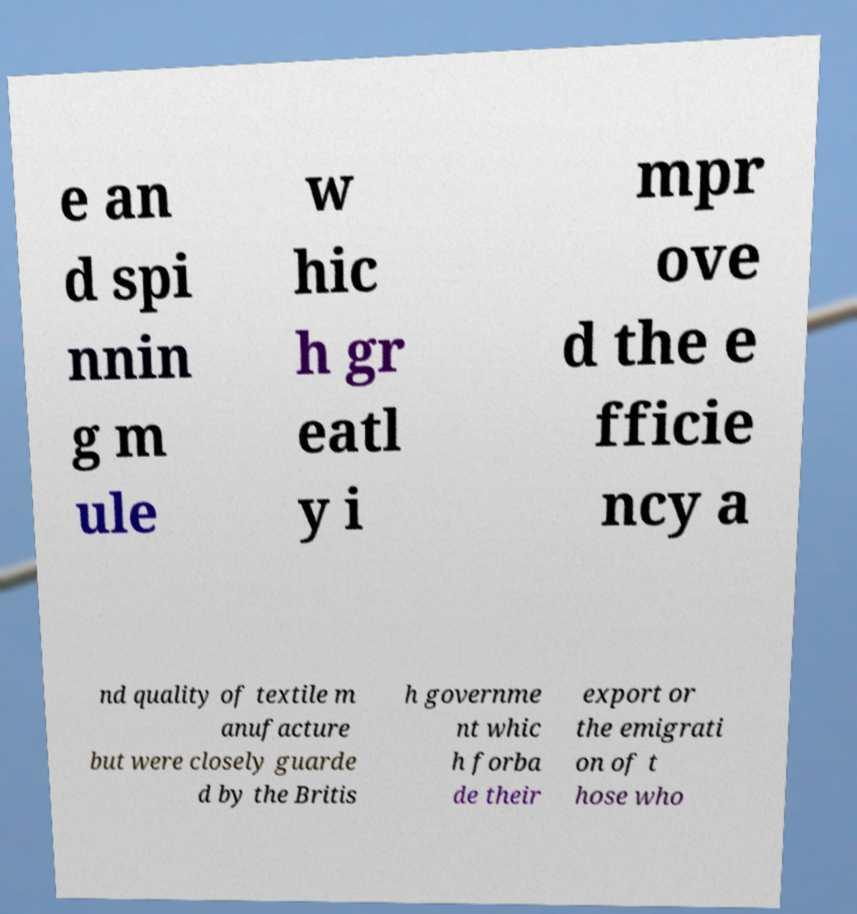Can you accurately transcribe the text from the provided image for me? e an d spi nnin g m ule w hic h gr eatl y i mpr ove d the e fficie ncy a nd quality of textile m anufacture but were closely guarde d by the Britis h governme nt whic h forba de their export or the emigrati on of t hose who 